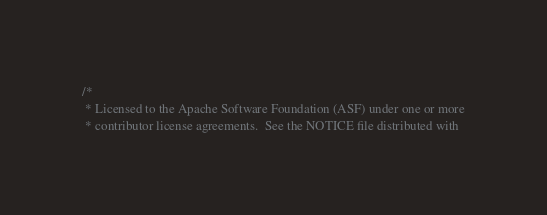Convert code to text. <code><loc_0><loc_0><loc_500><loc_500><_Scala_>/*
 * Licensed to the Apache Software Foundation (ASF) under one or more
 * contributor license agreements.  See the NOTICE file distributed with</code> 